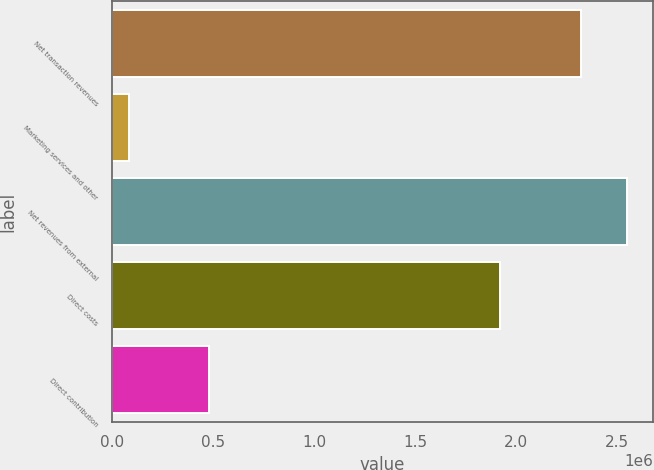Convert chart to OTSL. <chart><loc_0><loc_0><loc_500><loc_500><bar_chart><fcel>Net transaction revenues<fcel>Marketing services and other<fcel>Net revenues from external<fcel>Direct costs<fcel>Direct contribution<nl><fcel>2.3205e+06<fcel>83174<fcel>2.55254e+06<fcel>1.9229e+06<fcel>480772<nl></chart> 